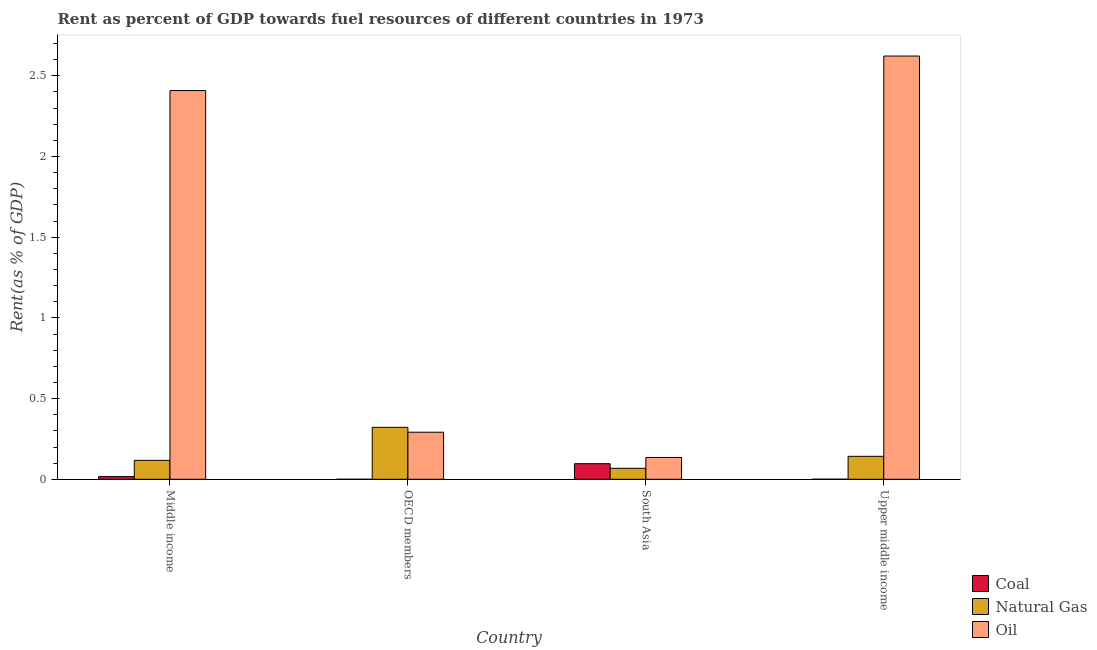What is the label of the 4th group of bars from the left?
Provide a succinct answer. Upper middle income. In how many cases, is the number of bars for a given country not equal to the number of legend labels?
Make the answer very short. 0. What is the rent towards coal in Upper middle income?
Keep it short and to the point. 0. Across all countries, what is the maximum rent towards oil?
Provide a short and direct response. 2.62. Across all countries, what is the minimum rent towards coal?
Provide a succinct answer. 1.50641686702978e-6. In which country was the rent towards coal maximum?
Your response must be concise. South Asia. In which country was the rent towards oil minimum?
Offer a terse response. South Asia. What is the total rent towards coal in the graph?
Your response must be concise. 0.11. What is the difference between the rent towards natural gas in Middle income and that in South Asia?
Your answer should be very brief. 0.05. What is the difference between the rent towards coal in OECD members and the rent towards oil in Middle income?
Keep it short and to the point. -2.41. What is the average rent towards oil per country?
Offer a terse response. 1.36. What is the difference between the rent towards natural gas and rent towards coal in Middle income?
Your answer should be compact. 0.1. In how many countries, is the rent towards coal greater than 1.9 %?
Your answer should be compact. 0. What is the ratio of the rent towards coal in OECD members to that in South Asia?
Make the answer very short. 1.559614286775328e-5. Is the difference between the rent towards coal in Middle income and OECD members greater than the difference between the rent towards oil in Middle income and OECD members?
Your answer should be very brief. No. What is the difference between the highest and the second highest rent towards oil?
Provide a succinct answer. 0.21. What is the difference between the highest and the lowest rent towards oil?
Offer a terse response. 2.49. Is the sum of the rent towards oil in Middle income and OECD members greater than the maximum rent towards natural gas across all countries?
Keep it short and to the point. Yes. What does the 1st bar from the left in Upper middle income represents?
Give a very brief answer. Coal. What does the 3rd bar from the right in Upper middle income represents?
Ensure brevity in your answer.  Coal. How many bars are there?
Keep it short and to the point. 12. Are the values on the major ticks of Y-axis written in scientific E-notation?
Ensure brevity in your answer.  No. Does the graph contain grids?
Offer a very short reply. No. How many legend labels are there?
Ensure brevity in your answer.  3. How are the legend labels stacked?
Your answer should be very brief. Vertical. What is the title of the graph?
Offer a very short reply. Rent as percent of GDP towards fuel resources of different countries in 1973. Does "Transport equipments" appear as one of the legend labels in the graph?
Offer a terse response. No. What is the label or title of the Y-axis?
Give a very brief answer. Rent(as % of GDP). What is the Rent(as % of GDP) in Coal in Middle income?
Offer a terse response. 0.02. What is the Rent(as % of GDP) in Natural Gas in Middle income?
Your response must be concise. 0.12. What is the Rent(as % of GDP) of Oil in Middle income?
Your response must be concise. 2.41. What is the Rent(as % of GDP) in Coal in OECD members?
Keep it short and to the point. 1.50641686702978e-6. What is the Rent(as % of GDP) in Natural Gas in OECD members?
Offer a terse response. 0.32. What is the Rent(as % of GDP) of Oil in OECD members?
Your answer should be very brief. 0.29. What is the Rent(as % of GDP) of Coal in South Asia?
Keep it short and to the point. 0.1. What is the Rent(as % of GDP) in Natural Gas in South Asia?
Make the answer very short. 0.07. What is the Rent(as % of GDP) of Oil in South Asia?
Provide a short and direct response. 0.14. What is the Rent(as % of GDP) in Coal in Upper middle income?
Ensure brevity in your answer.  0. What is the Rent(as % of GDP) of Natural Gas in Upper middle income?
Provide a short and direct response. 0.14. What is the Rent(as % of GDP) in Oil in Upper middle income?
Keep it short and to the point. 2.62. Across all countries, what is the maximum Rent(as % of GDP) in Coal?
Ensure brevity in your answer.  0.1. Across all countries, what is the maximum Rent(as % of GDP) of Natural Gas?
Give a very brief answer. 0.32. Across all countries, what is the maximum Rent(as % of GDP) of Oil?
Offer a very short reply. 2.62. Across all countries, what is the minimum Rent(as % of GDP) of Coal?
Make the answer very short. 1.50641686702978e-6. Across all countries, what is the minimum Rent(as % of GDP) of Natural Gas?
Offer a terse response. 0.07. Across all countries, what is the minimum Rent(as % of GDP) in Oil?
Provide a succinct answer. 0.14. What is the total Rent(as % of GDP) of Coal in the graph?
Your response must be concise. 0.11. What is the total Rent(as % of GDP) in Natural Gas in the graph?
Offer a terse response. 0.65. What is the total Rent(as % of GDP) in Oil in the graph?
Your response must be concise. 5.46. What is the difference between the Rent(as % of GDP) in Coal in Middle income and that in OECD members?
Offer a very short reply. 0.02. What is the difference between the Rent(as % of GDP) in Natural Gas in Middle income and that in OECD members?
Give a very brief answer. -0.2. What is the difference between the Rent(as % of GDP) of Oil in Middle income and that in OECD members?
Provide a short and direct response. 2.12. What is the difference between the Rent(as % of GDP) in Coal in Middle income and that in South Asia?
Your response must be concise. -0.08. What is the difference between the Rent(as % of GDP) of Natural Gas in Middle income and that in South Asia?
Offer a very short reply. 0.05. What is the difference between the Rent(as % of GDP) of Oil in Middle income and that in South Asia?
Provide a short and direct response. 2.27. What is the difference between the Rent(as % of GDP) in Coal in Middle income and that in Upper middle income?
Your response must be concise. 0.02. What is the difference between the Rent(as % of GDP) of Natural Gas in Middle income and that in Upper middle income?
Offer a very short reply. -0.03. What is the difference between the Rent(as % of GDP) of Oil in Middle income and that in Upper middle income?
Your answer should be compact. -0.21. What is the difference between the Rent(as % of GDP) of Coal in OECD members and that in South Asia?
Provide a succinct answer. -0.1. What is the difference between the Rent(as % of GDP) of Natural Gas in OECD members and that in South Asia?
Provide a short and direct response. 0.25. What is the difference between the Rent(as % of GDP) of Oil in OECD members and that in South Asia?
Make the answer very short. 0.16. What is the difference between the Rent(as % of GDP) of Coal in OECD members and that in Upper middle income?
Your answer should be very brief. -0. What is the difference between the Rent(as % of GDP) of Natural Gas in OECD members and that in Upper middle income?
Give a very brief answer. 0.18. What is the difference between the Rent(as % of GDP) in Oil in OECD members and that in Upper middle income?
Give a very brief answer. -2.33. What is the difference between the Rent(as % of GDP) in Coal in South Asia and that in Upper middle income?
Your answer should be compact. 0.1. What is the difference between the Rent(as % of GDP) in Natural Gas in South Asia and that in Upper middle income?
Your answer should be compact. -0.07. What is the difference between the Rent(as % of GDP) in Oil in South Asia and that in Upper middle income?
Your answer should be compact. -2.49. What is the difference between the Rent(as % of GDP) of Coal in Middle income and the Rent(as % of GDP) of Natural Gas in OECD members?
Keep it short and to the point. -0.31. What is the difference between the Rent(as % of GDP) in Coal in Middle income and the Rent(as % of GDP) in Oil in OECD members?
Offer a very short reply. -0.27. What is the difference between the Rent(as % of GDP) of Natural Gas in Middle income and the Rent(as % of GDP) of Oil in OECD members?
Ensure brevity in your answer.  -0.17. What is the difference between the Rent(as % of GDP) of Coal in Middle income and the Rent(as % of GDP) of Natural Gas in South Asia?
Provide a short and direct response. -0.05. What is the difference between the Rent(as % of GDP) in Coal in Middle income and the Rent(as % of GDP) in Oil in South Asia?
Your answer should be compact. -0.12. What is the difference between the Rent(as % of GDP) of Natural Gas in Middle income and the Rent(as % of GDP) of Oil in South Asia?
Your answer should be very brief. -0.02. What is the difference between the Rent(as % of GDP) of Coal in Middle income and the Rent(as % of GDP) of Natural Gas in Upper middle income?
Give a very brief answer. -0.13. What is the difference between the Rent(as % of GDP) of Coal in Middle income and the Rent(as % of GDP) of Oil in Upper middle income?
Offer a terse response. -2.61. What is the difference between the Rent(as % of GDP) of Natural Gas in Middle income and the Rent(as % of GDP) of Oil in Upper middle income?
Make the answer very short. -2.51. What is the difference between the Rent(as % of GDP) in Coal in OECD members and the Rent(as % of GDP) in Natural Gas in South Asia?
Your answer should be compact. -0.07. What is the difference between the Rent(as % of GDP) in Coal in OECD members and the Rent(as % of GDP) in Oil in South Asia?
Give a very brief answer. -0.14. What is the difference between the Rent(as % of GDP) in Natural Gas in OECD members and the Rent(as % of GDP) in Oil in South Asia?
Give a very brief answer. 0.19. What is the difference between the Rent(as % of GDP) of Coal in OECD members and the Rent(as % of GDP) of Natural Gas in Upper middle income?
Give a very brief answer. -0.14. What is the difference between the Rent(as % of GDP) in Coal in OECD members and the Rent(as % of GDP) in Oil in Upper middle income?
Keep it short and to the point. -2.62. What is the difference between the Rent(as % of GDP) of Natural Gas in OECD members and the Rent(as % of GDP) of Oil in Upper middle income?
Your answer should be compact. -2.3. What is the difference between the Rent(as % of GDP) of Coal in South Asia and the Rent(as % of GDP) of Natural Gas in Upper middle income?
Provide a short and direct response. -0.05. What is the difference between the Rent(as % of GDP) in Coal in South Asia and the Rent(as % of GDP) in Oil in Upper middle income?
Offer a very short reply. -2.53. What is the difference between the Rent(as % of GDP) of Natural Gas in South Asia and the Rent(as % of GDP) of Oil in Upper middle income?
Offer a very short reply. -2.55. What is the average Rent(as % of GDP) of Coal per country?
Your answer should be very brief. 0.03. What is the average Rent(as % of GDP) of Natural Gas per country?
Provide a succinct answer. 0.16. What is the average Rent(as % of GDP) of Oil per country?
Your response must be concise. 1.36. What is the difference between the Rent(as % of GDP) in Coal and Rent(as % of GDP) in Natural Gas in Middle income?
Make the answer very short. -0.1. What is the difference between the Rent(as % of GDP) in Coal and Rent(as % of GDP) in Oil in Middle income?
Offer a terse response. -2.39. What is the difference between the Rent(as % of GDP) of Natural Gas and Rent(as % of GDP) of Oil in Middle income?
Offer a terse response. -2.29. What is the difference between the Rent(as % of GDP) in Coal and Rent(as % of GDP) in Natural Gas in OECD members?
Ensure brevity in your answer.  -0.32. What is the difference between the Rent(as % of GDP) in Coal and Rent(as % of GDP) in Oil in OECD members?
Make the answer very short. -0.29. What is the difference between the Rent(as % of GDP) of Natural Gas and Rent(as % of GDP) of Oil in OECD members?
Keep it short and to the point. 0.03. What is the difference between the Rent(as % of GDP) in Coal and Rent(as % of GDP) in Natural Gas in South Asia?
Offer a terse response. 0.03. What is the difference between the Rent(as % of GDP) in Coal and Rent(as % of GDP) in Oil in South Asia?
Make the answer very short. -0.04. What is the difference between the Rent(as % of GDP) of Natural Gas and Rent(as % of GDP) of Oil in South Asia?
Your answer should be very brief. -0.07. What is the difference between the Rent(as % of GDP) of Coal and Rent(as % of GDP) of Natural Gas in Upper middle income?
Give a very brief answer. -0.14. What is the difference between the Rent(as % of GDP) in Coal and Rent(as % of GDP) in Oil in Upper middle income?
Offer a terse response. -2.62. What is the difference between the Rent(as % of GDP) in Natural Gas and Rent(as % of GDP) in Oil in Upper middle income?
Your answer should be compact. -2.48. What is the ratio of the Rent(as % of GDP) in Coal in Middle income to that in OECD members?
Provide a short and direct response. 1.12e+04. What is the ratio of the Rent(as % of GDP) of Natural Gas in Middle income to that in OECD members?
Provide a short and direct response. 0.36. What is the ratio of the Rent(as % of GDP) in Oil in Middle income to that in OECD members?
Make the answer very short. 8.26. What is the ratio of the Rent(as % of GDP) of Coal in Middle income to that in South Asia?
Your answer should be compact. 0.17. What is the ratio of the Rent(as % of GDP) of Natural Gas in Middle income to that in South Asia?
Ensure brevity in your answer.  1.72. What is the ratio of the Rent(as % of GDP) in Oil in Middle income to that in South Asia?
Give a very brief answer. 17.84. What is the ratio of the Rent(as % of GDP) in Coal in Middle income to that in Upper middle income?
Your answer should be very brief. 39.04. What is the ratio of the Rent(as % of GDP) of Natural Gas in Middle income to that in Upper middle income?
Offer a terse response. 0.82. What is the ratio of the Rent(as % of GDP) of Oil in Middle income to that in Upper middle income?
Offer a terse response. 0.92. What is the ratio of the Rent(as % of GDP) in Coal in OECD members to that in South Asia?
Make the answer very short. 0. What is the ratio of the Rent(as % of GDP) of Natural Gas in OECD members to that in South Asia?
Give a very brief answer. 4.73. What is the ratio of the Rent(as % of GDP) in Oil in OECD members to that in South Asia?
Your response must be concise. 2.16. What is the ratio of the Rent(as % of GDP) of Coal in OECD members to that in Upper middle income?
Offer a very short reply. 0. What is the ratio of the Rent(as % of GDP) in Natural Gas in OECD members to that in Upper middle income?
Your answer should be compact. 2.26. What is the ratio of the Rent(as % of GDP) in Oil in OECD members to that in Upper middle income?
Your answer should be very brief. 0.11. What is the ratio of the Rent(as % of GDP) in Coal in South Asia to that in Upper middle income?
Your answer should be compact. 224.18. What is the ratio of the Rent(as % of GDP) in Natural Gas in South Asia to that in Upper middle income?
Your answer should be very brief. 0.48. What is the ratio of the Rent(as % of GDP) in Oil in South Asia to that in Upper middle income?
Your response must be concise. 0.05. What is the difference between the highest and the second highest Rent(as % of GDP) of Coal?
Give a very brief answer. 0.08. What is the difference between the highest and the second highest Rent(as % of GDP) in Natural Gas?
Ensure brevity in your answer.  0.18. What is the difference between the highest and the second highest Rent(as % of GDP) of Oil?
Ensure brevity in your answer.  0.21. What is the difference between the highest and the lowest Rent(as % of GDP) of Coal?
Your answer should be compact. 0.1. What is the difference between the highest and the lowest Rent(as % of GDP) of Natural Gas?
Provide a short and direct response. 0.25. What is the difference between the highest and the lowest Rent(as % of GDP) of Oil?
Provide a short and direct response. 2.49. 